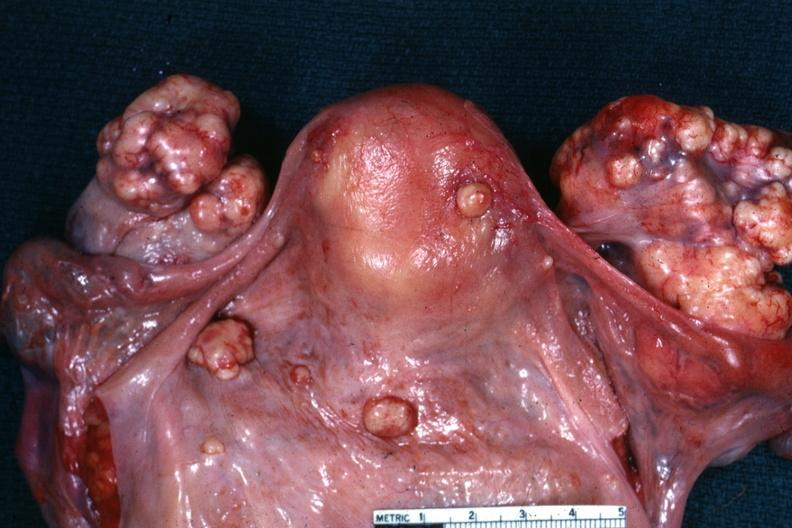how is this true krukenberg?
Answer the question using a single word or phrase. Bilateral 